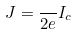Convert formula to latex. <formula><loc_0><loc_0><loc_500><loc_500>J = \frac { } { 2 e } I _ { c }</formula> 